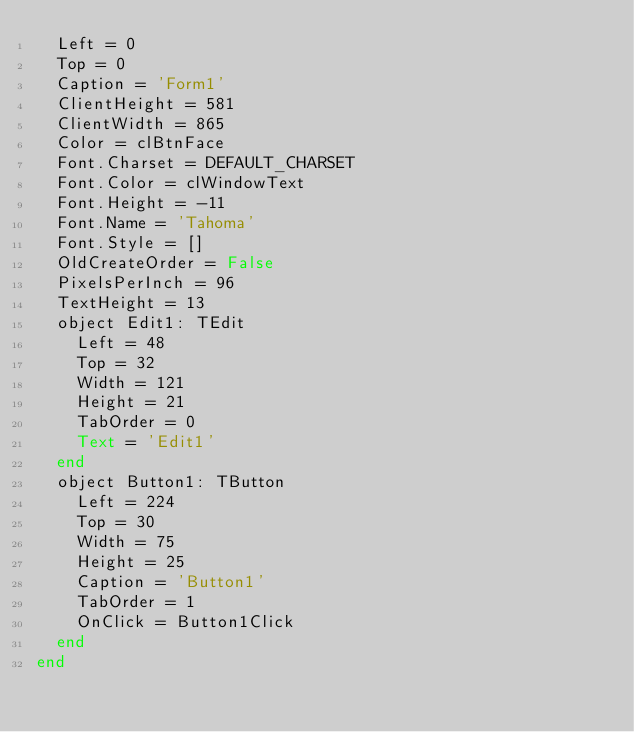Convert code to text. <code><loc_0><loc_0><loc_500><loc_500><_Pascal_>  Left = 0
  Top = 0
  Caption = 'Form1'
  ClientHeight = 581
  ClientWidth = 865
  Color = clBtnFace
  Font.Charset = DEFAULT_CHARSET
  Font.Color = clWindowText
  Font.Height = -11
  Font.Name = 'Tahoma'
  Font.Style = []
  OldCreateOrder = False
  PixelsPerInch = 96
  TextHeight = 13
  object Edit1: TEdit
    Left = 48
    Top = 32
    Width = 121
    Height = 21
    TabOrder = 0
    Text = 'Edit1'
  end
  object Button1: TButton
    Left = 224
    Top = 30
    Width = 75
    Height = 25
    Caption = 'Button1'
    TabOrder = 1
    OnClick = Button1Click
  end
end
</code> 